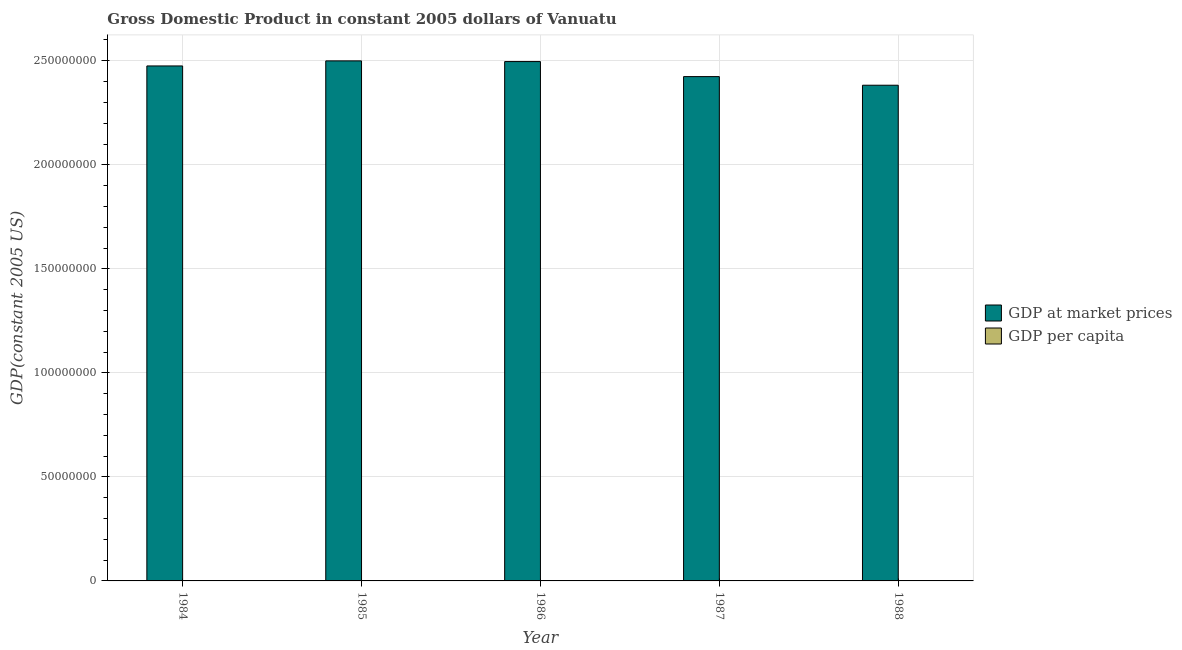How many bars are there on the 3rd tick from the right?
Your response must be concise. 2. What is the gdp per capita in 1986?
Give a very brief answer. 1876.35. Across all years, what is the maximum gdp at market prices?
Provide a short and direct response. 2.50e+08. Across all years, what is the minimum gdp per capita?
Provide a succinct answer. 1709.53. In which year was the gdp per capita maximum?
Provide a short and direct response. 1984. What is the total gdp at market prices in the graph?
Your answer should be very brief. 1.23e+09. What is the difference between the gdp per capita in 1984 and that in 1988?
Provide a short and direct response. 238.03. What is the difference between the gdp at market prices in 1988 and the gdp per capita in 1984?
Offer a terse response. -9.27e+06. What is the average gdp per capita per year?
Keep it short and to the point. 1847.3. In the year 1985, what is the difference between the gdp at market prices and gdp per capita?
Provide a succinct answer. 0. In how many years, is the gdp per capita greater than 40000000 US$?
Ensure brevity in your answer.  0. What is the ratio of the gdp per capita in 1985 to that in 1987?
Offer a very short reply. 1.08. What is the difference between the highest and the second highest gdp at market prices?
Offer a very short reply. 3.30e+05. What is the difference between the highest and the lowest gdp at market prices?
Provide a short and direct response. 1.17e+07. In how many years, is the gdp per capita greater than the average gdp per capita taken over all years?
Make the answer very short. 3. Is the sum of the gdp at market prices in 1985 and 1988 greater than the maximum gdp per capita across all years?
Your answer should be very brief. Yes. What does the 2nd bar from the left in 1985 represents?
Your response must be concise. GDP per capita. What does the 2nd bar from the right in 1986 represents?
Give a very brief answer. GDP at market prices. Are all the bars in the graph horizontal?
Keep it short and to the point. No. What is the difference between two consecutive major ticks on the Y-axis?
Provide a short and direct response. 5.00e+07. Does the graph contain grids?
Give a very brief answer. Yes. Where does the legend appear in the graph?
Your response must be concise. Center right. What is the title of the graph?
Keep it short and to the point. Gross Domestic Product in constant 2005 dollars of Vanuatu. Does "Mineral" appear as one of the legend labels in the graph?
Make the answer very short. No. What is the label or title of the X-axis?
Keep it short and to the point. Year. What is the label or title of the Y-axis?
Your answer should be compact. GDP(constant 2005 US). What is the GDP(constant 2005 US) in GDP at market prices in 1984?
Give a very brief answer. 2.48e+08. What is the GDP(constant 2005 US) of GDP per capita in 1984?
Offer a terse response. 1947.56. What is the GDP(constant 2005 US) of GDP at market prices in 1985?
Ensure brevity in your answer.  2.50e+08. What is the GDP(constant 2005 US) of GDP per capita in 1985?
Offer a very short reply. 1922.35. What is the GDP(constant 2005 US) of GDP at market prices in 1986?
Your response must be concise. 2.50e+08. What is the GDP(constant 2005 US) in GDP per capita in 1986?
Make the answer very short. 1876.35. What is the GDP(constant 2005 US) of GDP at market prices in 1987?
Ensure brevity in your answer.  2.42e+08. What is the GDP(constant 2005 US) in GDP per capita in 1987?
Offer a very short reply. 1780.7. What is the GDP(constant 2005 US) of GDP at market prices in 1988?
Offer a very short reply. 2.38e+08. What is the GDP(constant 2005 US) of GDP per capita in 1988?
Your response must be concise. 1709.53. Across all years, what is the maximum GDP(constant 2005 US) in GDP at market prices?
Ensure brevity in your answer.  2.50e+08. Across all years, what is the maximum GDP(constant 2005 US) of GDP per capita?
Your response must be concise. 1947.56. Across all years, what is the minimum GDP(constant 2005 US) of GDP at market prices?
Your answer should be compact. 2.38e+08. Across all years, what is the minimum GDP(constant 2005 US) in GDP per capita?
Keep it short and to the point. 1709.53. What is the total GDP(constant 2005 US) in GDP at market prices in the graph?
Your answer should be very brief. 1.23e+09. What is the total GDP(constant 2005 US) of GDP per capita in the graph?
Give a very brief answer. 9236.49. What is the difference between the GDP(constant 2005 US) of GDP at market prices in 1984 and that in 1985?
Keep it short and to the point. -2.44e+06. What is the difference between the GDP(constant 2005 US) of GDP per capita in 1984 and that in 1985?
Your response must be concise. 25.21. What is the difference between the GDP(constant 2005 US) in GDP at market prices in 1984 and that in 1986?
Offer a very short reply. -2.11e+06. What is the difference between the GDP(constant 2005 US) in GDP per capita in 1984 and that in 1986?
Give a very brief answer. 71.22. What is the difference between the GDP(constant 2005 US) in GDP at market prices in 1984 and that in 1987?
Give a very brief answer. 5.12e+06. What is the difference between the GDP(constant 2005 US) in GDP per capita in 1984 and that in 1987?
Provide a short and direct response. 166.86. What is the difference between the GDP(constant 2005 US) of GDP at market prices in 1984 and that in 1988?
Your response must be concise. 9.27e+06. What is the difference between the GDP(constant 2005 US) in GDP per capita in 1984 and that in 1988?
Provide a short and direct response. 238.03. What is the difference between the GDP(constant 2005 US) of GDP at market prices in 1985 and that in 1986?
Make the answer very short. 3.30e+05. What is the difference between the GDP(constant 2005 US) in GDP per capita in 1985 and that in 1986?
Your answer should be very brief. 46. What is the difference between the GDP(constant 2005 US) of GDP at market prices in 1985 and that in 1987?
Your answer should be very brief. 7.55e+06. What is the difference between the GDP(constant 2005 US) in GDP per capita in 1985 and that in 1987?
Your response must be concise. 141.65. What is the difference between the GDP(constant 2005 US) of GDP at market prices in 1985 and that in 1988?
Offer a very short reply. 1.17e+07. What is the difference between the GDP(constant 2005 US) of GDP per capita in 1985 and that in 1988?
Your answer should be very brief. 212.82. What is the difference between the GDP(constant 2005 US) of GDP at market prices in 1986 and that in 1987?
Your answer should be very brief. 7.22e+06. What is the difference between the GDP(constant 2005 US) of GDP per capita in 1986 and that in 1987?
Your answer should be very brief. 95.65. What is the difference between the GDP(constant 2005 US) of GDP at market prices in 1986 and that in 1988?
Give a very brief answer. 1.14e+07. What is the difference between the GDP(constant 2005 US) of GDP per capita in 1986 and that in 1988?
Make the answer very short. 166.81. What is the difference between the GDP(constant 2005 US) in GDP at market prices in 1987 and that in 1988?
Provide a short and direct response. 4.15e+06. What is the difference between the GDP(constant 2005 US) of GDP per capita in 1987 and that in 1988?
Ensure brevity in your answer.  71.17. What is the difference between the GDP(constant 2005 US) of GDP at market prices in 1984 and the GDP(constant 2005 US) of GDP per capita in 1985?
Your response must be concise. 2.48e+08. What is the difference between the GDP(constant 2005 US) in GDP at market prices in 1984 and the GDP(constant 2005 US) in GDP per capita in 1986?
Ensure brevity in your answer.  2.48e+08. What is the difference between the GDP(constant 2005 US) of GDP at market prices in 1984 and the GDP(constant 2005 US) of GDP per capita in 1987?
Offer a very short reply. 2.48e+08. What is the difference between the GDP(constant 2005 US) of GDP at market prices in 1984 and the GDP(constant 2005 US) of GDP per capita in 1988?
Give a very brief answer. 2.48e+08. What is the difference between the GDP(constant 2005 US) in GDP at market prices in 1985 and the GDP(constant 2005 US) in GDP per capita in 1986?
Provide a short and direct response. 2.50e+08. What is the difference between the GDP(constant 2005 US) of GDP at market prices in 1985 and the GDP(constant 2005 US) of GDP per capita in 1987?
Provide a succinct answer. 2.50e+08. What is the difference between the GDP(constant 2005 US) of GDP at market prices in 1985 and the GDP(constant 2005 US) of GDP per capita in 1988?
Your answer should be very brief. 2.50e+08. What is the difference between the GDP(constant 2005 US) in GDP at market prices in 1986 and the GDP(constant 2005 US) in GDP per capita in 1987?
Your answer should be compact. 2.50e+08. What is the difference between the GDP(constant 2005 US) of GDP at market prices in 1986 and the GDP(constant 2005 US) of GDP per capita in 1988?
Your answer should be very brief. 2.50e+08. What is the difference between the GDP(constant 2005 US) of GDP at market prices in 1987 and the GDP(constant 2005 US) of GDP per capita in 1988?
Your response must be concise. 2.42e+08. What is the average GDP(constant 2005 US) in GDP at market prices per year?
Keep it short and to the point. 2.46e+08. What is the average GDP(constant 2005 US) in GDP per capita per year?
Keep it short and to the point. 1847.3. In the year 1984, what is the difference between the GDP(constant 2005 US) in GDP at market prices and GDP(constant 2005 US) in GDP per capita?
Provide a short and direct response. 2.48e+08. In the year 1985, what is the difference between the GDP(constant 2005 US) of GDP at market prices and GDP(constant 2005 US) of GDP per capita?
Offer a very short reply. 2.50e+08. In the year 1986, what is the difference between the GDP(constant 2005 US) in GDP at market prices and GDP(constant 2005 US) in GDP per capita?
Offer a very short reply. 2.50e+08. In the year 1987, what is the difference between the GDP(constant 2005 US) of GDP at market prices and GDP(constant 2005 US) of GDP per capita?
Make the answer very short. 2.42e+08. In the year 1988, what is the difference between the GDP(constant 2005 US) in GDP at market prices and GDP(constant 2005 US) in GDP per capita?
Your answer should be very brief. 2.38e+08. What is the ratio of the GDP(constant 2005 US) in GDP at market prices in 1984 to that in 1985?
Your response must be concise. 0.99. What is the ratio of the GDP(constant 2005 US) in GDP per capita in 1984 to that in 1985?
Offer a very short reply. 1.01. What is the ratio of the GDP(constant 2005 US) of GDP per capita in 1984 to that in 1986?
Your response must be concise. 1.04. What is the ratio of the GDP(constant 2005 US) of GDP at market prices in 1984 to that in 1987?
Your answer should be very brief. 1.02. What is the ratio of the GDP(constant 2005 US) of GDP per capita in 1984 to that in 1987?
Your response must be concise. 1.09. What is the ratio of the GDP(constant 2005 US) in GDP at market prices in 1984 to that in 1988?
Keep it short and to the point. 1.04. What is the ratio of the GDP(constant 2005 US) of GDP per capita in 1984 to that in 1988?
Offer a terse response. 1.14. What is the ratio of the GDP(constant 2005 US) of GDP per capita in 1985 to that in 1986?
Your answer should be compact. 1.02. What is the ratio of the GDP(constant 2005 US) in GDP at market prices in 1985 to that in 1987?
Your response must be concise. 1.03. What is the ratio of the GDP(constant 2005 US) in GDP per capita in 1985 to that in 1987?
Give a very brief answer. 1.08. What is the ratio of the GDP(constant 2005 US) in GDP at market prices in 1985 to that in 1988?
Provide a short and direct response. 1.05. What is the ratio of the GDP(constant 2005 US) of GDP per capita in 1985 to that in 1988?
Keep it short and to the point. 1.12. What is the ratio of the GDP(constant 2005 US) in GDP at market prices in 1986 to that in 1987?
Ensure brevity in your answer.  1.03. What is the ratio of the GDP(constant 2005 US) of GDP per capita in 1986 to that in 1987?
Provide a succinct answer. 1.05. What is the ratio of the GDP(constant 2005 US) of GDP at market prices in 1986 to that in 1988?
Give a very brief answer. 1.05. What is the ratio of the GDP(constant 2005 US) of GDP per capita in 1986 to that in 1988?
Provide a succinct answer. 1.1. What is the ratio of the GDP(constant 2005 US) of GDP at market prices in 1987 to that in 1988?
Provide a short and direct response. 1.02. What is the ratio of the GDP(constant 2005 US) of GDP per capita in 1987 to that in 1988?
Offer a terse response. 1.04. What is the difference between the highest and the second highest GDP(constant 2005 US) in GDP at market prices?
Offer a very short reply. 3.30e+05. What is the difference between the highest and the second highest GDP(constant 2005 US) of GDP per capita?
Offer a terse response. 25.21. What is the difference between the highest and the lowest GDP(constant 2005 US) in GDP at market prices?
Offer a terse response. 1.17e+07. What is the difference between the highest and the lowest GDP(constant 2005 US) in GDP per capita?
Your answer should be very brief. 238.03. 